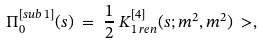<formula> <loc_0><loc_0><loc_500><loc_500>\Pi ^ { [ s u b \, 1 ] } _ { 0 } ( s ) & \ = \ \frac { 1 } { 2 } \ K ^ { [ 4 ] } _ { 1 \, r e n } ( s ; m ^ { 2 } , m ^ { 2 } ) \ > ,</formula> 